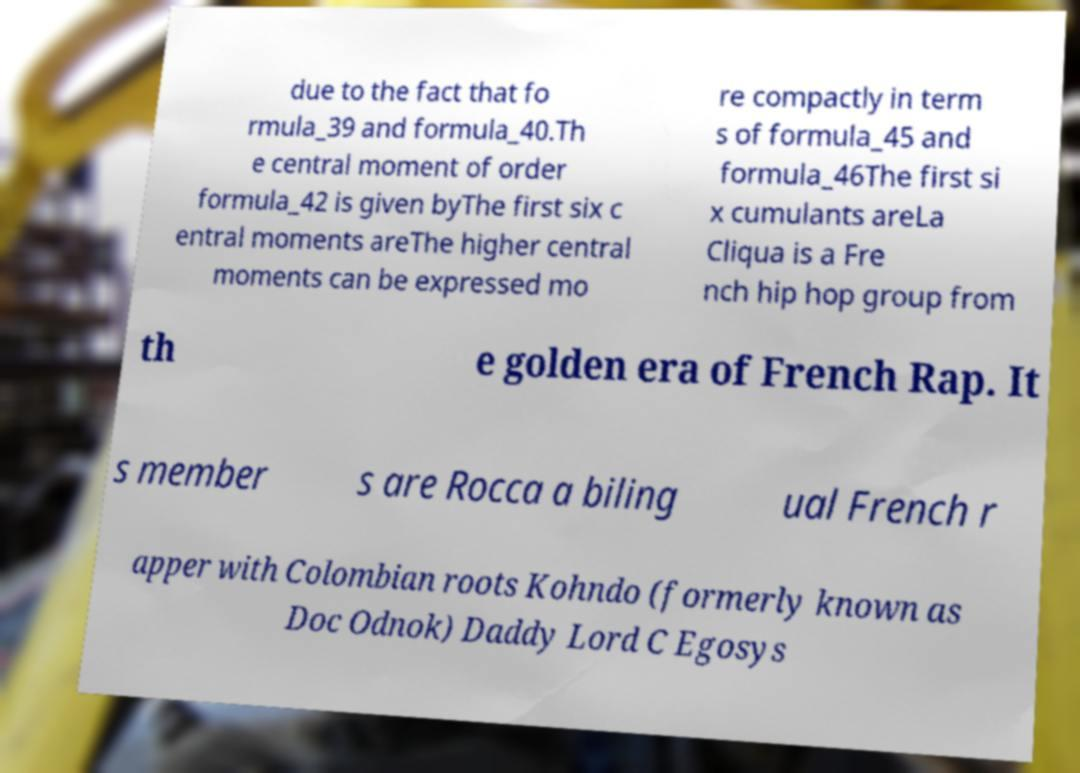For documentation purposes, I need the text within this image transcribed. Could you provide that? due to the fact that fo rmula_39 and formula_40.Th e central moment of order formula_42 is given byThe first six c entral moments areThe higher central moments can be expressed mo re compactly in term s of formula_45 and formula_46The first si x cumulants areLa Cliqua is a Fre nch hip hop group from th e golden era of French Rap. It s member s are Rocca a biling ual French r apper with Colombian roots Kohndo (formerly known as Doc Odnok) Daddy Lord C Egosys 